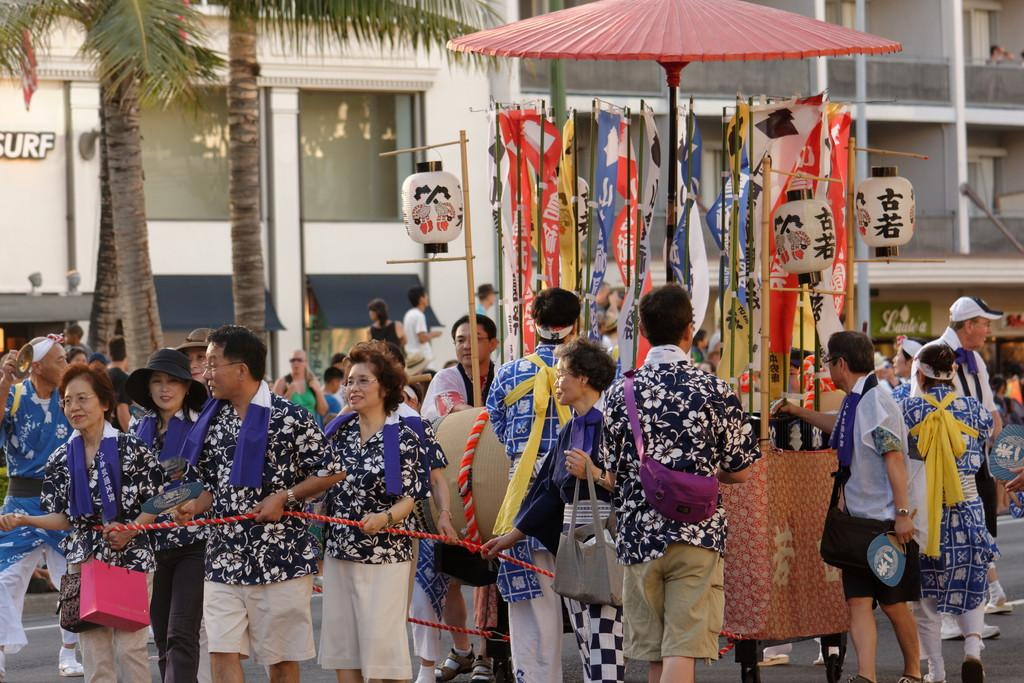How many people are in the image? There is a group of people in the image, but the exact number is not specified. What are some people doing in the image? Some people are holding a rope in the image. What can be seen in the background of the image? In the background of the image, there are flags, paper lanterns, trees, and buildings. What type of drink is being served at the home in the image? There is no home or drink present in the image. Is there a crook in the image? There is no crook present in the image. 